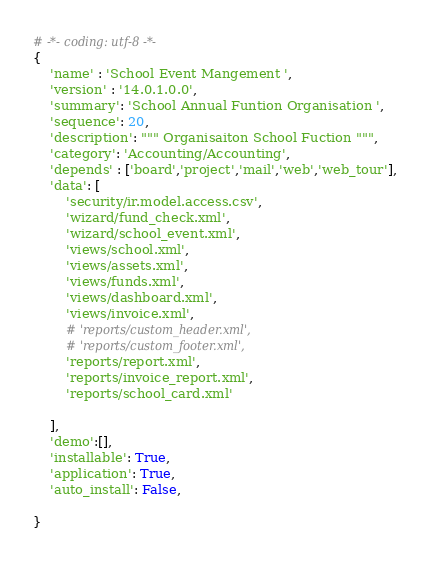<code> <loc_0><loc_0><loc_500><loc_500><_Python_># -*- coding: utf-8 -*-
{
    'name' : 'School Event Mangement ',
    'version' : '14.0.1.0.0',
    'summary': 'School Annual Funtion Organisation ',
    'sequence': 20,
    'description': """ Organisaiton School Fuction """,
    'category': 'Accounting/Accounting',
    'depends' : ['board','project','mail','web','web_tour'],
    'data': [
        'security/ir.model.access.csv',
        'wizard/fund_check.xml',
        'wizard/school_event.xml',
        'views/school.xml',
        'views/assets.xml',
        'views/funds.xml',
        'views/dashboard.xml',
        'views/invoice.xml',
        # 'reports/custom_header.xml',
        # 'reports/custom_footer.xml',
        'reports/report.xml',
        'reports/invoice_report.xml',
        'reports/school_card.xml'

    ],
    'demo':[],
    'installable': True,
    'application': True,
    'auto_install': False,
    
}
</code> 